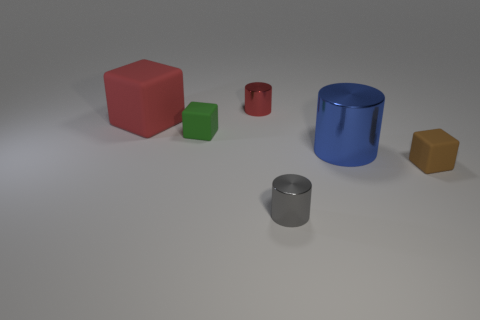Does the big blue cylinder have the same material as the green block?
Your answer should be compact. No. There is a thing that is the same color as the big rubber cube; what size is it?
Make the answer very short. Small. What is the shape of the small shiny object that is the same color as the large matte thing?
Keep it short and to the point. Cylinder. How big is the thing that is to the left of the small matte block left of the cylinder behind the large metal thing?
Your answer should be compact. Large. What is the green thing made of?
Your answer should be compact. Rubber. Are the brown block and the green thing behind the gray cylinder made of the same material?
Provide a succinct answer. Yes. Is there anything else of the same color as the big matte thing?
Make the answer very short. Yes. There is a tiny rubber thing to the right of the tiny cylinder in front of the red metal cylinder; are there any blue things left of it?
Offer a very short reply. Yes. What color is the large rubber thing?
Keep it short and to the point. Red. There is a large red block; are there any gray things right of it?
Keep it short and to the point. Yes. 